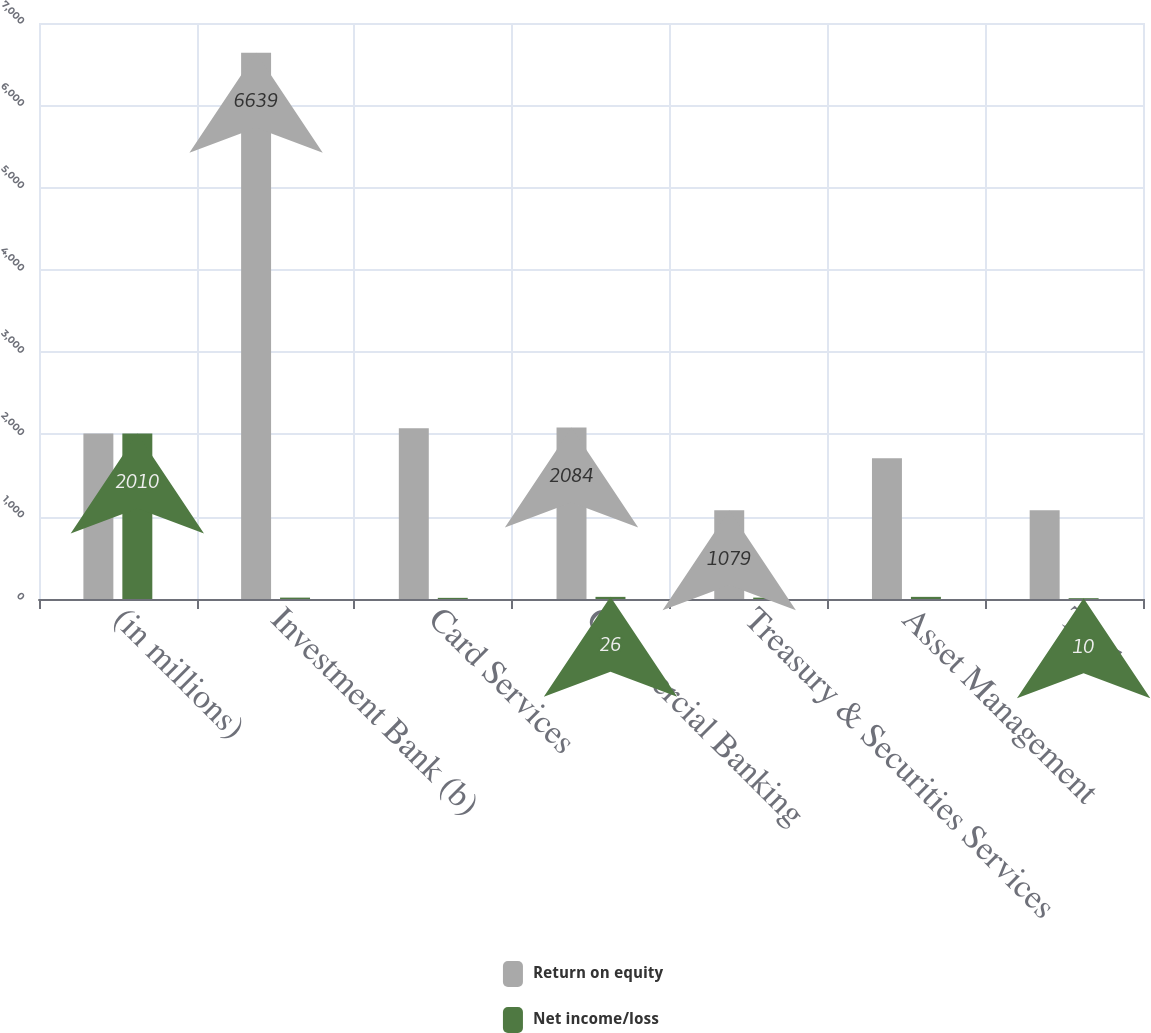Convert chart. <chart><loc_0><loc_0><loc_500><loc_500><stacked_bar_chart><ecel><fcel>(in millions)<fcel>Investment Bank (b)<fcel>Card Services<fcel>Commercial Banking<fcel>Treasury & Securities Services<fcel>Asset Management<fcel>Total<nl><fcel>Return on equity<fcel>2010<fcel>6639<fcel>2074<fcel>2084<fcel>1079<fcel>1710<fcel>1079<nl><fcel>Net income/loss<fcel>2010<fcel>17<fcel>14<fcel>26<fcel>17<fcel>26<fcel>10<nl></chart> 